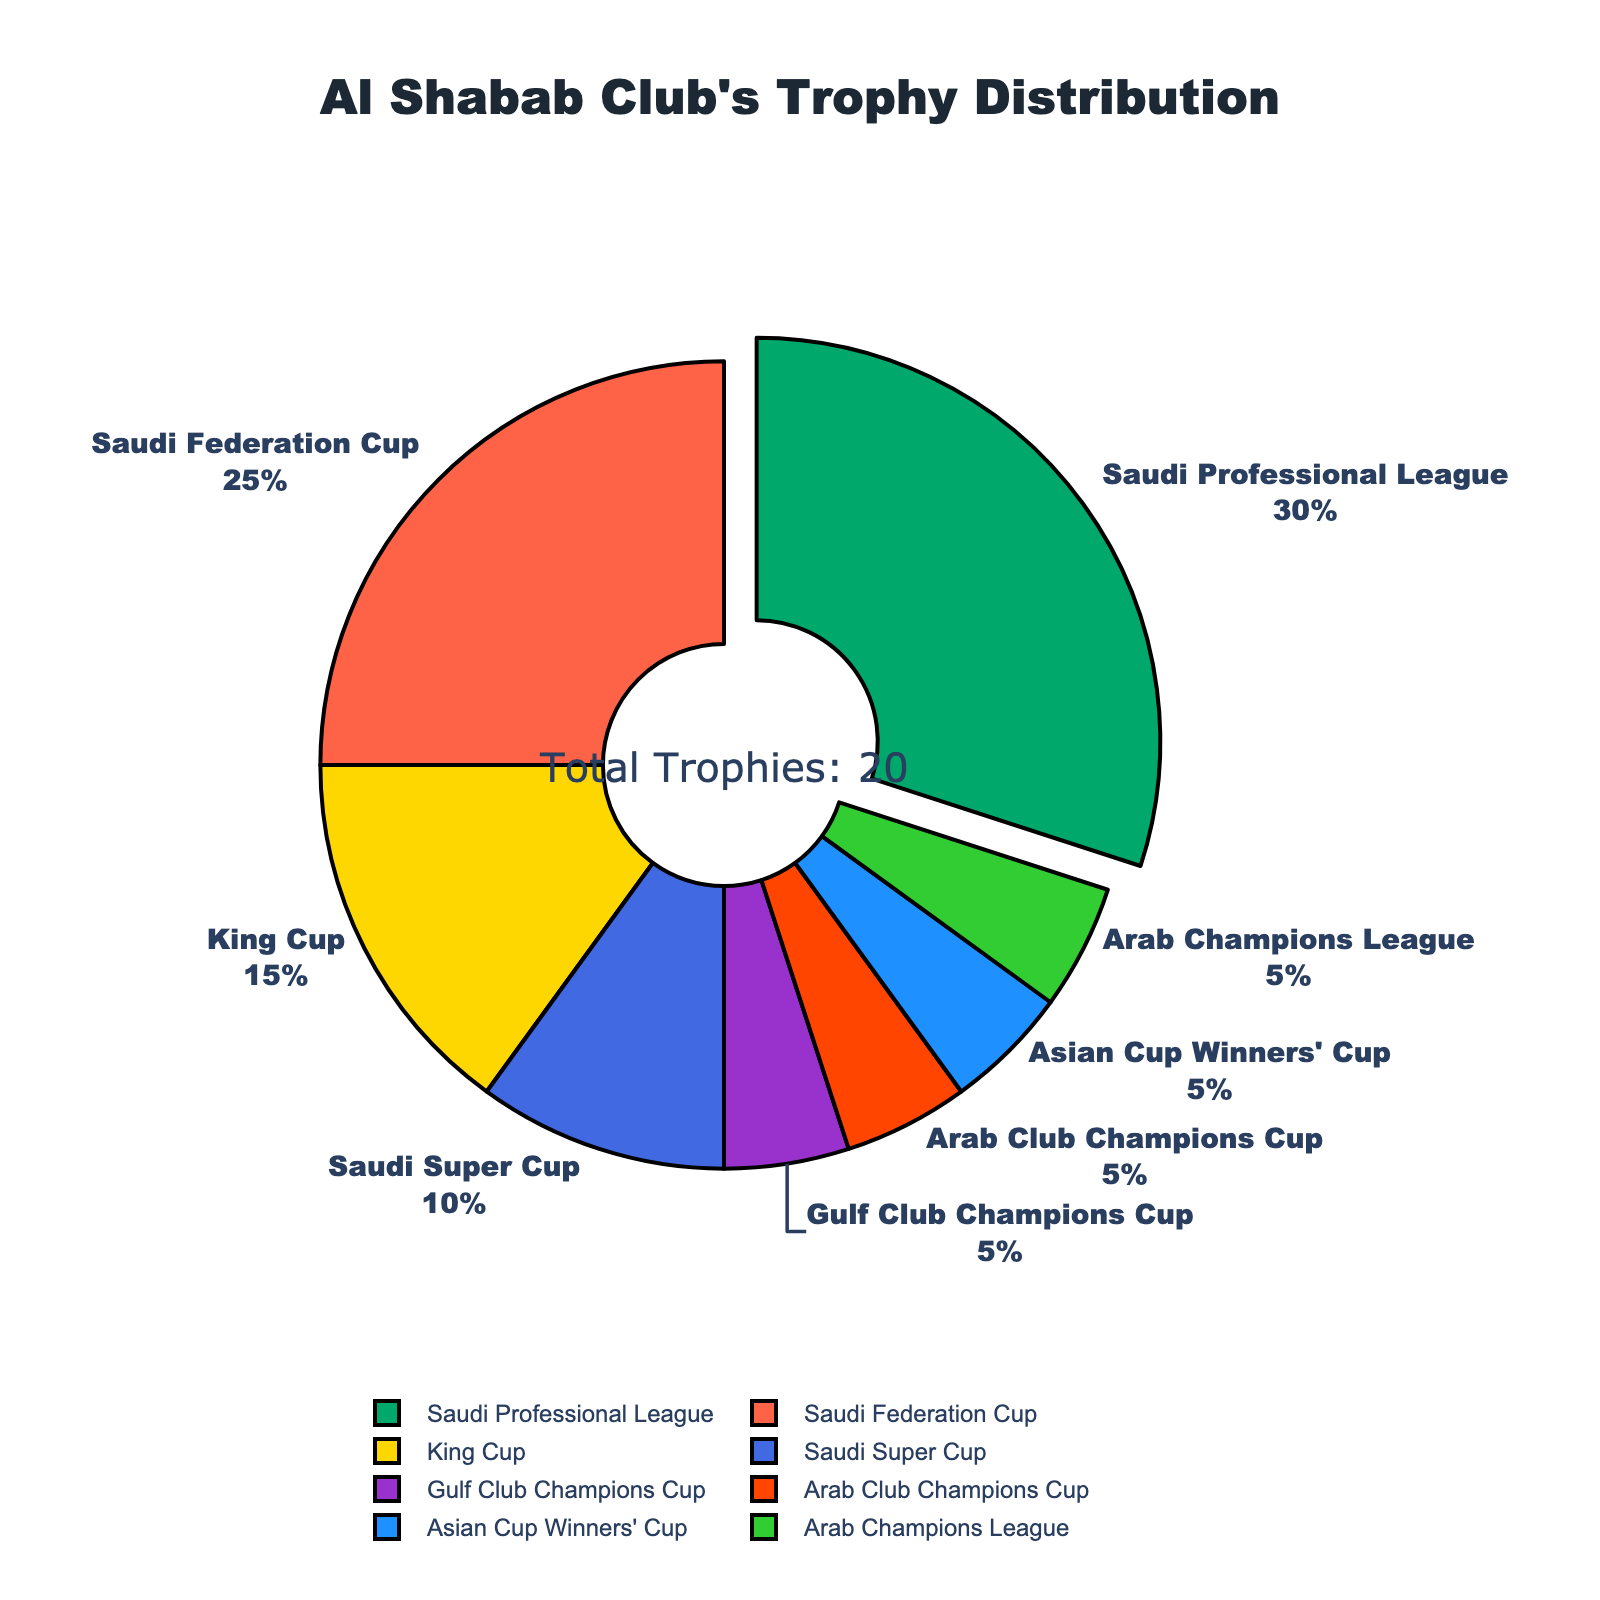Which competition does Al Shabab Club hold the highest number of trophies in? The pie chart visually highlights that the Saudi Professional League section is slightly pulled out and the largest, meaning it has the highest percentage share among all the competitions.
Answer: Saudi Professional League How many trophies in total has Al Shabab Club won in the 'Saudi Federation Cup' and 'King Cup'? The pie chart shows that Al Shabab Club has 5 trophies in the Saudi Federation Cup and 3 trophies in the King Cup. Sum them up, 5 + 3 = 8.
Answer: 8 Which two competitions have the least number of trophies for Al Shabab Club? The pie chart segments with the smallest slices, almost identical in size, each representing 1 trophy are the Gulf Club Champions Cup, Arab Club Champions Cup, Asian Cup Winners' Cup, and Arab Champions League. From these, any two can be selected.
Answer: Gulf Club Champions Cup, Arab Club Champions Cup If the 'Saudi Professional League' represents 50% of the total trophies, how many trophies does this competition represent and what is the total number of trophies won by Al Shabab Club? Calculate the theoretical total number of trophies by dividing the number of Saudi Professional League trophies (6) by the percentage it represents (50%), which is calculating 6 / 0.5 = 12.
Answer: 12 How many more trophies does Al Shabab Club have in the 'Saudi Super Cup' compared to the 'Arab Club Champions Cup'? The pie chart shows 2 trophies in the Saudi Super Cup and 1 trophy in the Arab Club Champions Cup. Subtracting, 2 - 1 = 1.
Answer: 1 Which competition has 3 trophies and what percentage does it account for? The King Cup section of the pie chart has 3 trophies. To find the percentage, divide 3 by the total number of trophies (20) and multiply by 100, resulting in (3/20) * 100 = 15%.
Answer: King Cup, 15% Is the number of trophies in the 'Asian Cup Winners' Cup' more or less than the 'Saudi Super Cup'? The pie chart indicates there is 1 trophy in the Asian Cup Winners' Cup and 2 trophies in the Saudi Super Cup. Thus, the Asian Cup Winners' Cup has fewer trophies.
Answer: Less What visual attribute most readily indicates the competition with the most trophies? The visual attribute that indicates the competition with the most trophies is the slightly pulled out 'Saudi Professional League' slice, along with its largest relative area on the pie chart.
Answer: Pulled out slice & largest area 